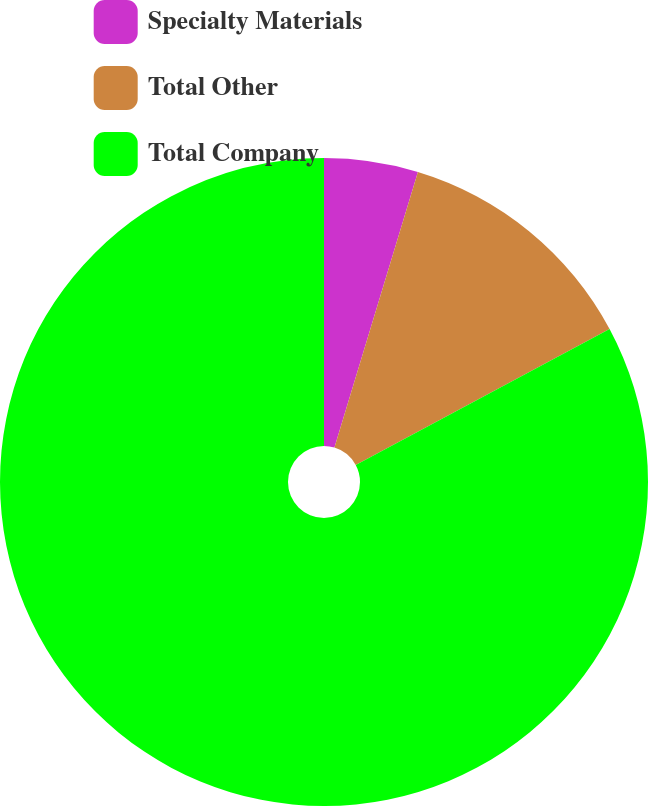Convert chart to OTSL. <chart><loc_0><loc_0><loc_500><loc_500><pie_chart><fcel>Specialty Materials<fcel>Total Other<fcel>Total Company<nl><fcel>4.68%<fcel>12.49%<fcel>82.83%<nl></chart> 